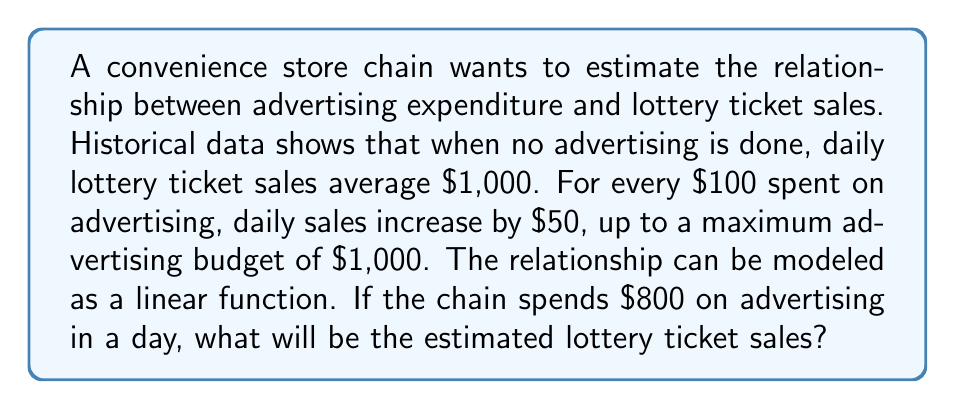Teach me how to tackle this problem. Let's approach this step-by-step:

1) First, we need to identify the linear function that models this relationship. The general form of a linear function is:

   $$ y = mx + b $$

   where $y$ is the lottery ticket sales, $x$ is the advertising expenditure, $m$ is the slope, and $b$ is the y-intercept.

2) We're given that when no advertising is done ($x = 0$), sales are $1,000. This means $b = 1,000$.

3) We're also told that for every $100 spent on advertising, sales increase by $50. This gives us the slope:

   $$ m = \frac{50}{100} = 0.5 $$

4) So our linear function is:

   $$ y = 0.5x + 1000 $$

5) Now, we want to find $y$ when $x = 800$. Let's substitute this into our equation:

   $$ y = 0.5(800) + 1000 $$

6) Simplify:

   $$ y = 400 + 1000 = 1400 $$

Therefore, when $800 is spent on advertising, the estimated lottery ticket sales will be $1,400.
Answer: $1,400 